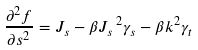Convert formula to latex. <formula><loc_0><loc_0><loc_500><loc_500>\frac { \partial ^ { 2 } f } { \partial s ^ { 2 } } = J _ { s } - \beta J _ { s } \, ^ { 2 } \gamma _ { s } - \beta k ^ { 2 } \gamma _ { t }</formula> 